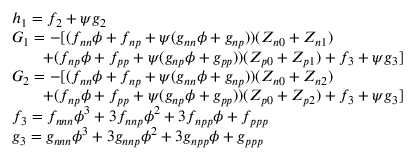Convert formula to latex. <formula><loc_0><loc_0><loc_500><loc_500>\begin{array} { l } { h _ { 1 } = f _ { 2 } + \psi g _ { 2 } } \\ { G _ { 1 } = - [ ( f _ { n n } \phi + f _ { n p } + \psi ( g _ { n n } \phi + g _ { n p } ) ) ( Z _ { n 0 } + Z _ { n 1 } ) } \\ { \quad + ( f _ { n p } \phi + f _ { p p } + \psi ( g _ { n p } \phi + g _ { p p } ) ) ( Z _ { p 0 } + Z _ { p 1 } ) + f _ { 3 } + \psi g _ { 3 } ] } \\ { G _ { 2 } = - [ ( f _ { n n } \phi + f _ { n p } + \psi ( g _ { n n } \phi + g _ { n p } ) ) ( Z _ { n 0 } + Z _ { n 2 } ) } \\ { \quad + ( f _ { n p } \phi + f _ { p p } + \psi ( g _ { n p } \phi + g _ { p p } ) ) ( Z _ { p 0 } + Z _ { p 2 } ) + f _ { 3 } + \psi g _ { 3 } ] } \\ { f _ { 3 } = f _ { n n n } \phi ^ { 3 } + 3 f _ { n n p } \phi ^ { 2 } + 3 f _ { n p p } \phi + f _ { p p p } } \\ { g _ { 3 } = g _ { n n n } \phi ^ { 3 } + 3 g _ { n n p } \phi ^ { 2 } + 3 g _ { n p p } \phi + g _ { p p p } } \end{array}</formula> 